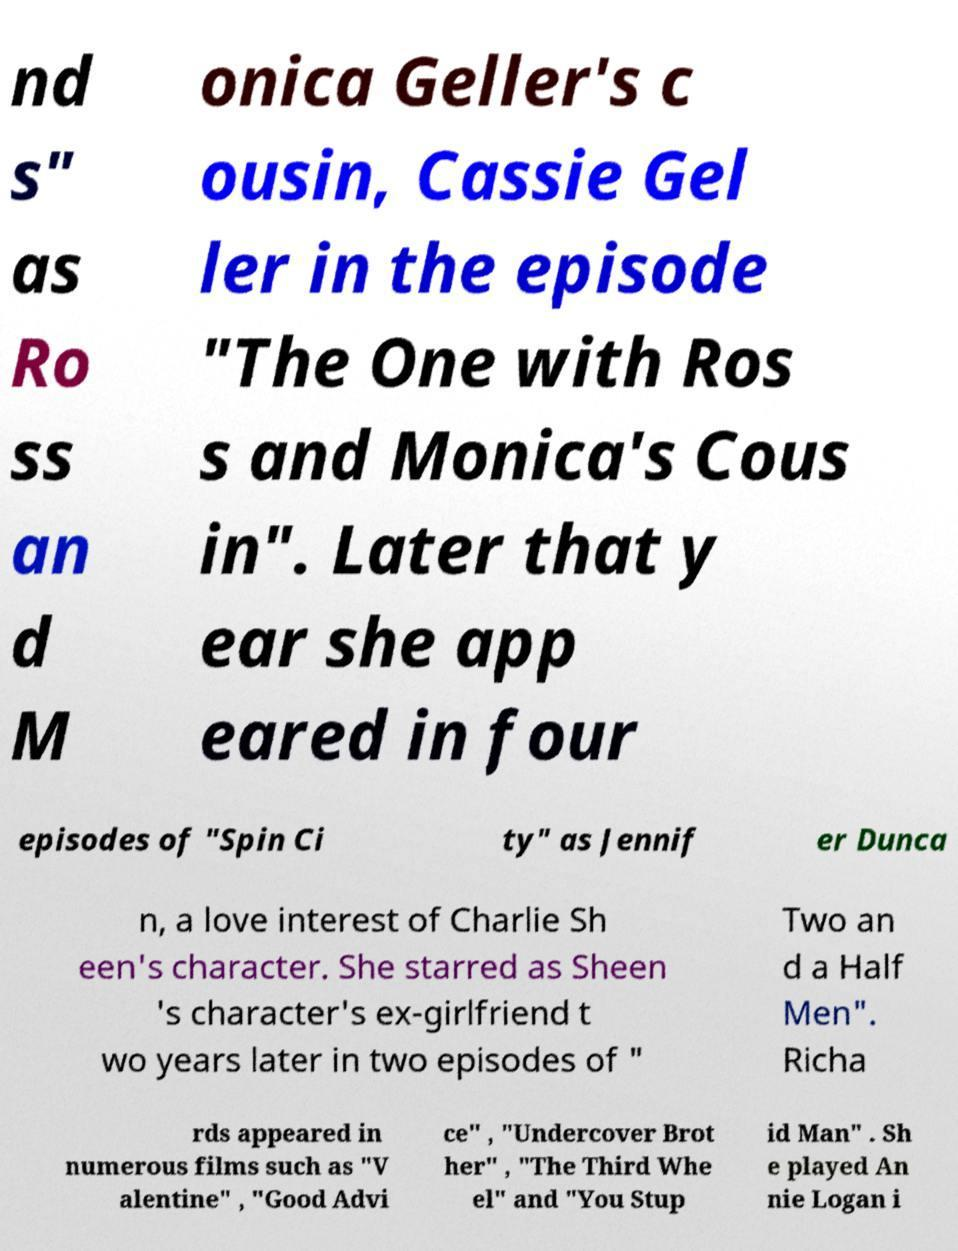Could you assist in decoding the text presented in this image and type it out clearly? nd s" as Ro ss an d M onica Geller's c ousin, Cassie Gel ler in the episode "The One with Ros s and Monica's Cous in". Later that y ear she app eared in four episodes of "Spin Ci ty" as Jennif er Dunca n, a love interest of Charlie Sh een's character. She starred as Sheen 's character's ex-girlfriend t wo years later in two episodes of " Two an d a Half Men". Richa rds appeared in numerous films such as "V alentine" , "Good Advi ce" , "Undercover Brot her" , "The Third Whe el" and "You Stup id Man" . Sh e played An nie Logan i 